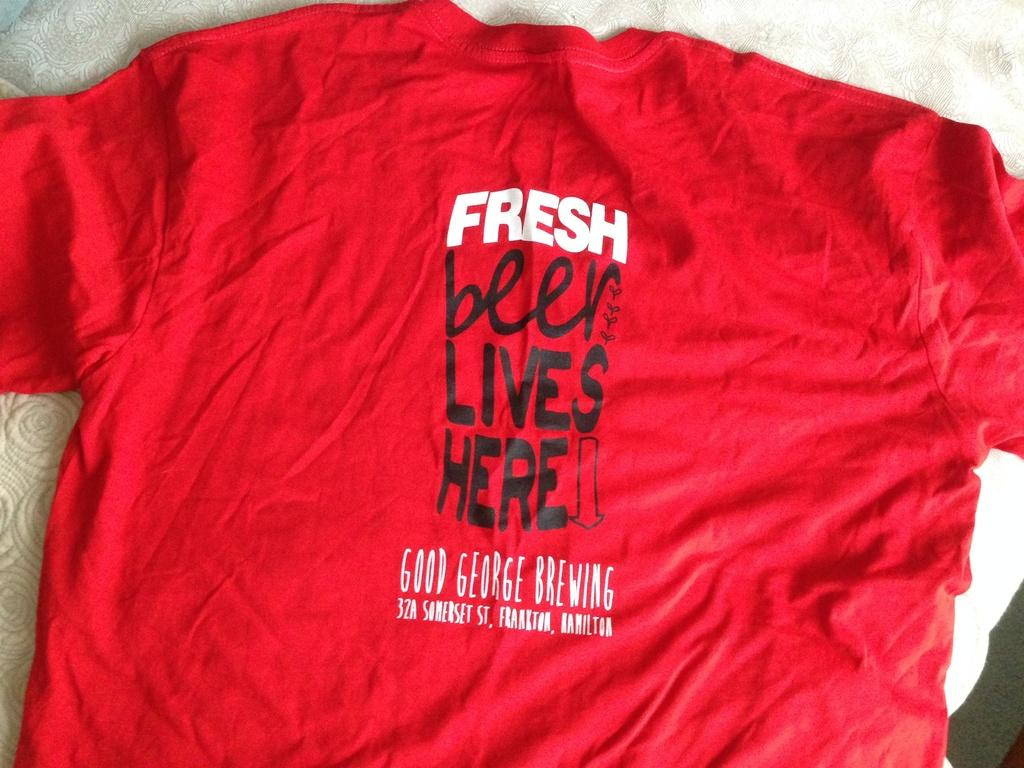<image>
Render a clear and concise summary of the photo. Red T shirt that says fresh beer lives here 